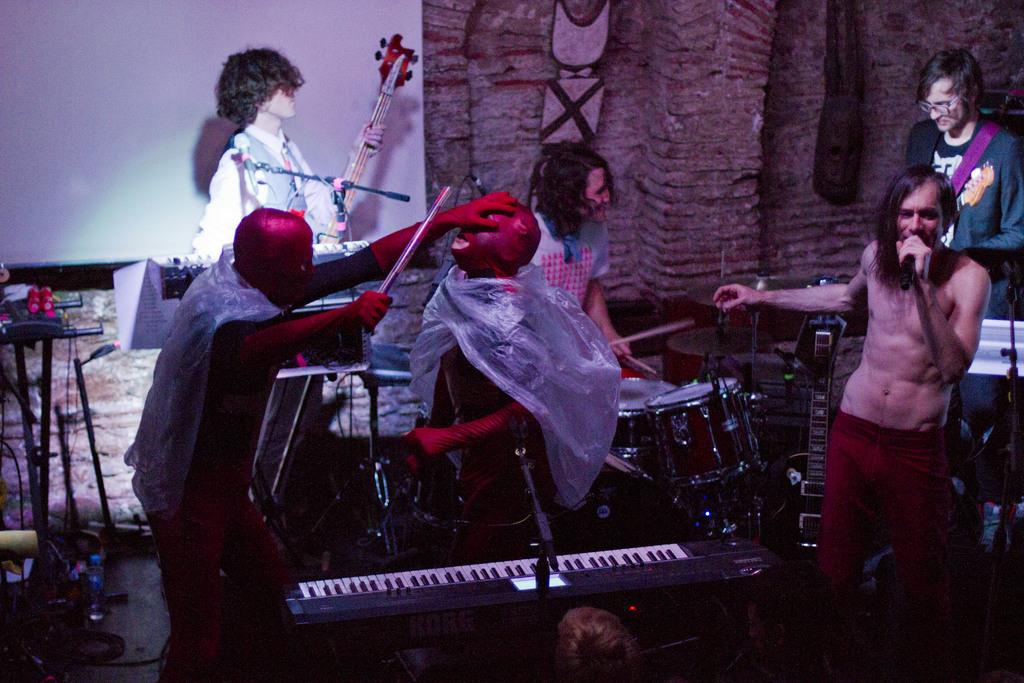What is the person wearing in the image? The person is wearing red pants in the image. What is the person doing in the image? The person is singing in front of a microphone. What are the people in the background doing? The people in the background are playing music. What can be seen in front of the piano? There are people in red costumes standing in front of a piano. What type of hydrant can be seen in the image? There is no hydrant visible in the image. What role does the porter play in the musical performance? There is no porter mentioned or depicted in the image. 